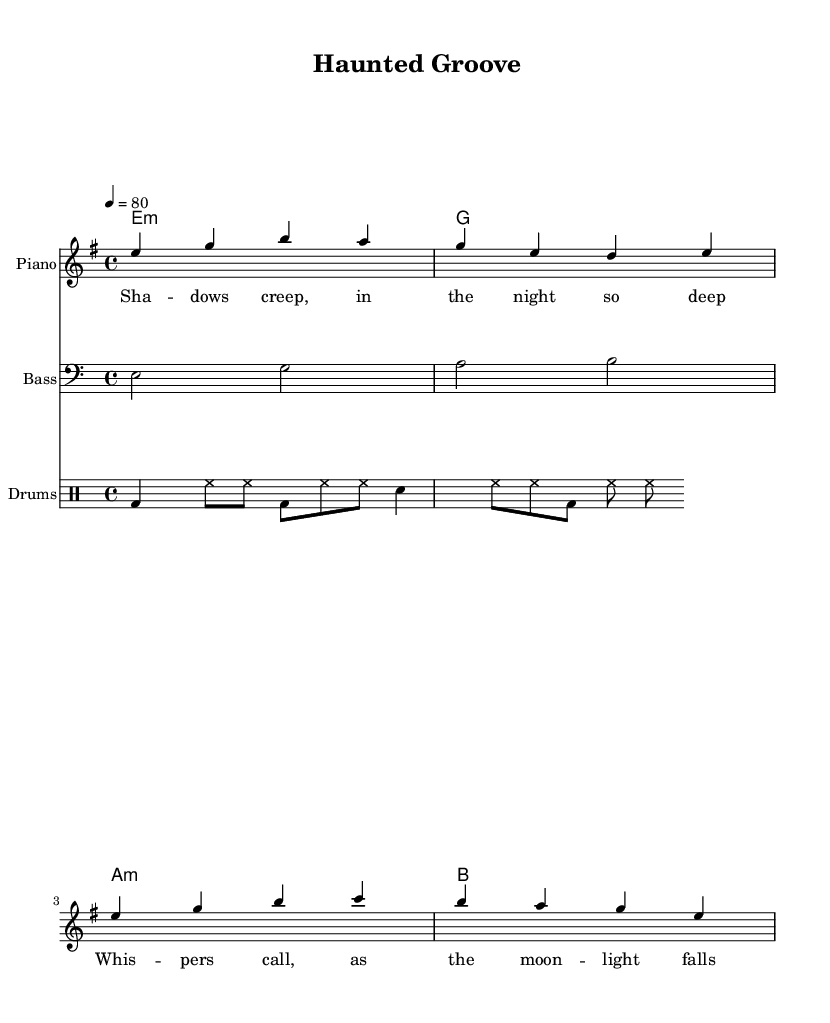What is the key signature of this music? The key signature indicates E minor, which has one sharp (F#). This can be determined by looking at the key indicated in the global settings of the score.
Answer: E minor What is the time signature of this music? The time signature is 4/4, which means there are four beats per measure and the quarter note receives one beat. This is specified in the global settings section of the sheet music.
Answer: 4/4 What is the tempo marking of this score? The tempo marking is 80 beats per minute, indicated by the tempo statement in the global settings. This indicates the speed at which the music should be played.
Answer: 80 How many measures are in the melody? The melody consists of 4 measures, as can be counted by looking at the melody section. Each grouping of notes corresponds to one measure.
Answer: 4 What is the chord that accompanies the first measure? The chord accompanying the first measure is E minor, found in the harmonies section where the chords are listed. The notation "e1:m" indicates an E minor chord for one whole note.
Answer: E minor What differentiates Rhythm and Blues from other genres in this piece? The presence of a strong backbeat from the drums and the use of syncopated rhythms contribute to the characteristic feel of Rhythm and Blues. Additionally, the haunting melody complements the spooky theme typical of R&B. This can be inferred from the specific instrumentation and rhythmic patterns used in the score.
Answer: Strong backbeat What is the main theme conveyed by the lyrics? The lyrics reflect a spooky atmosphere, describing shadows and whispers at night. They add to the Halloween party theme, implying a haunting yet rhythmic ambiance suitable for an R&B anthem. The choice of words conveys an eerie setting.
Answer: Spooky atmosphere 